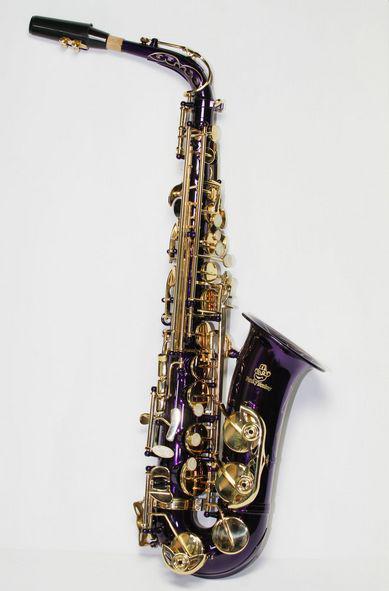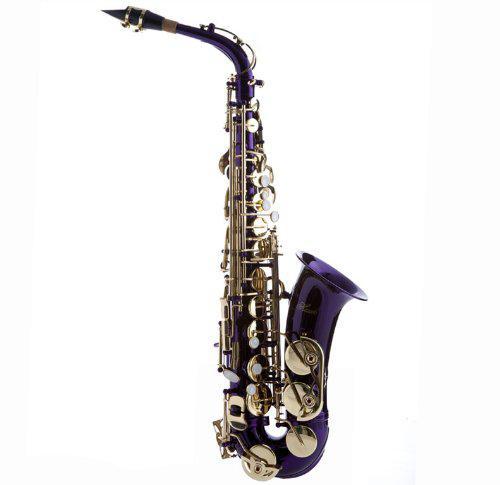The first image is the image on the left, the second image is the image on the right. Assess this claim about the two images: "You can see an entire saxophone in both photos.". Correct or not? Answer yes or no. Yes. 